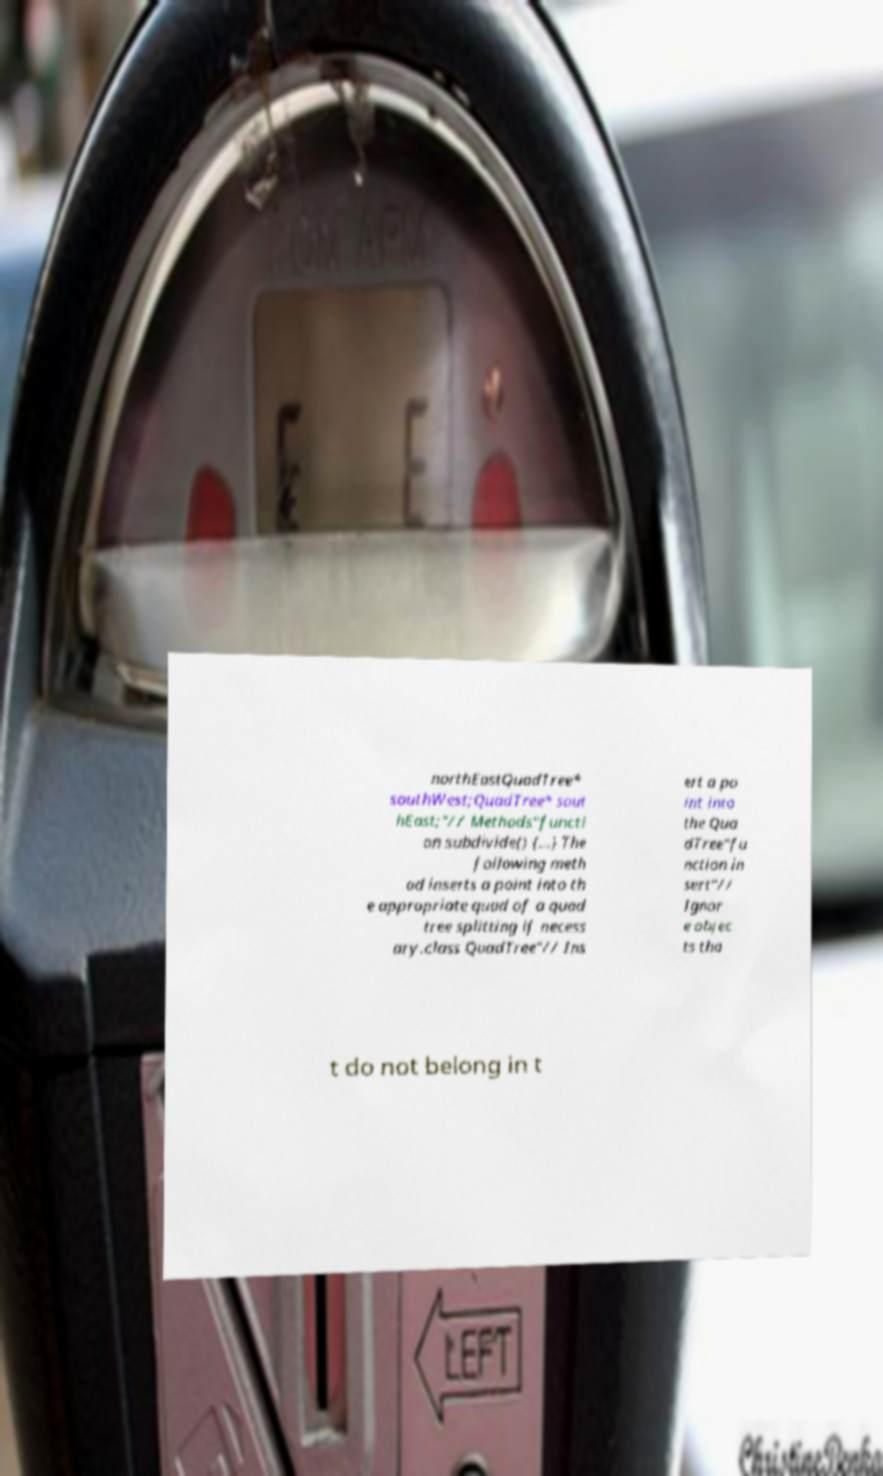Could you extract and type out the text from this image? northEastQuadTree* southWest;QuadTree* sout hEast;"// Methods"functi on subdivide() {...} The following meth od inserts a point into th e appropriate quad of a quad tree splitting if necess ary.class QuadTree"// Ins ert a po int into the Qua dTree"fu nction in sert"// Ignor e objec ts tha t do not belong in t 